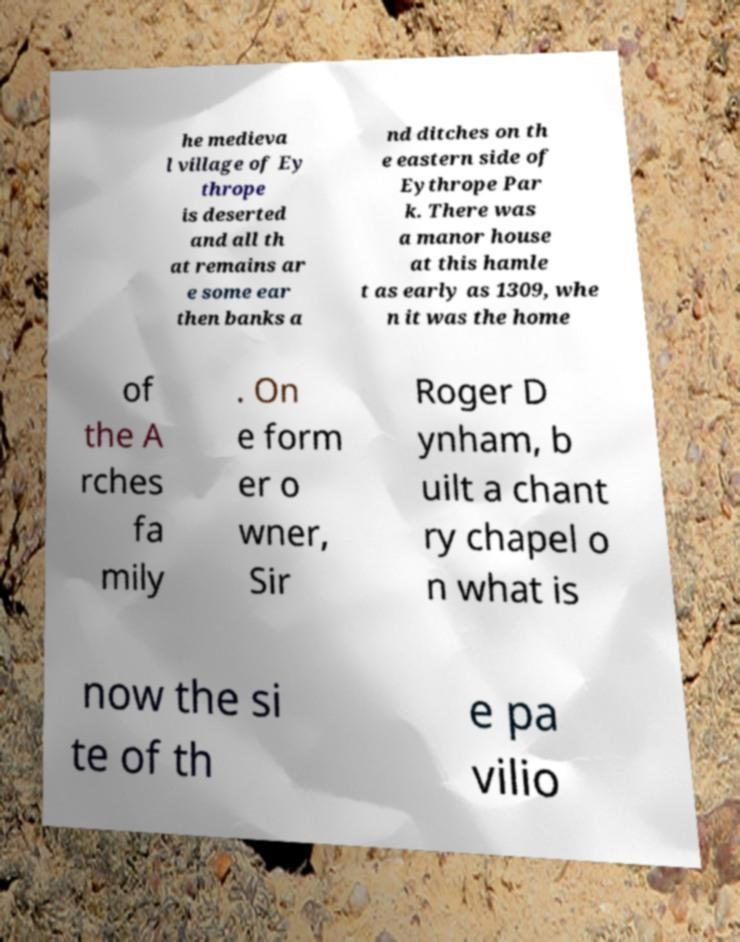Please read and relay the text visible in this image. What does it say? he medieva l village of Ey thrope is deserted and all th at remains ar e some ear then banks a nd ditches on th e eastern side of Eythrope Par k. There was a manor house at this hamle t as early as 1309, whe n it was the home of the A rches fa mily . On e form er o wner, Sir Roger D ynham, b uilt a chant ry chapel o n what is now the si te of th e pa vilio 